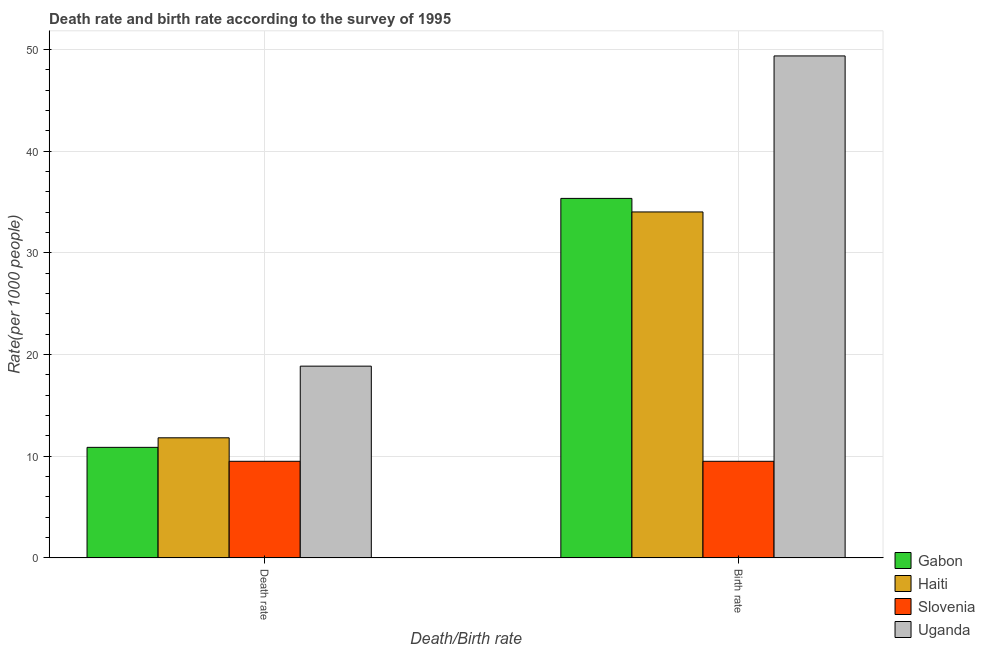How many different coloured bars are there?
Give a very brief answer. 4. Are the number of bars per tick equal to the number of legend labels?
Provide a succinct answer. Yes. Are the number of bars on each tick of the X-axis equal?
Your response must be concise. Yes. How many bars are there on the 1st tick from the left?
Offer a very short reply. 4. What is the label of the 1st group of bars from the left?
Give a very brief answer. Death rate. What is the birth rate in Gabon?
Provide a succinct answer. 35.35. Across all countries, what is the maximum birth rate?
Offer a terse response. 49.36. In which country was the birth rate maximum?
Keep it short and to the point. Uganda. In which country was the birth rate minimum?
Keep it short and to the point. Slovenia. What is the total birth rate in the graph?
Make the answer very short. 128.23. What is the difference between the death rate in Uganda and that in Gabon?
Offer a very short reply. 7.99. What is the difference between the birth rate in Gabon and the death rate in Haiti?
Offer a very short reply. 23.54. What is the average birth rate per country?
Provide a short and direct response. 32.06. What is the difference between the death rate and birth rate in Uganda?
Keep it short and to the point. -30.51. In how many countries, is the birth rate greater than 48 ?
Provide a short and direct response. 1. What is the ratio of the death rate in Uganda to that in Haiti?
Provide a short and direct response. 1.6. What does the 2nd bar from the left in Birth rate represents?
Give a very brief answer. Haiti. What does the 3rd bar from the right in Death rate represents?
Keep it short and to the point. Haiti. Are the values on the major ticks of Y-axis written in scientific E-notation?
Keep it short and to the point. No. Does the graph contain grids?
Make the answer very short. Yes. What is the title of the graph?
Make the answer very short. Death rate and birth rate according to the survey of 1995. What is the label or title of the X-axis?
Provide a succinct answer. Death/Birth rate. What is the label or title of the Y-axis?
Provide a short and direct response. Rate(per 1000 people). What is the Rate(per 1000 people) in Gabon in Death rate?
Keep it short and to the point. 10.87. What is the Rate(per 1000 people) in Haiti in Death rate?
Your answer should be compact. 11.81. What is the Rate(per 1000 people) in Slovenia in Death rate?
Your answer should be very brief. 9.5. What is the Rate(per 1000 people) in Uganda in Death rate?
Keep it short and to the point. 18.86. What is the Rate(per 1000 people) in Gabon in Birth rate?
Provide a succinct answer. 35.35. What is the Rate(per 1000 people) in Haiti in Birth rate?
Your answer should be very brief. 34.02. What is the Rate(per 1000 people) of Slovenia in Birth rate?
Make the answer very short. 9.5. What is the Rate(per 1000 people) of Uganda in Birth rate?
Your answer should be very brief. 49.36. Across all Death/Birth rate, what is the maximum Rate(per 1000 people) of Gabon?
Provide a succinct answer. 35.35. Across all Death/Birth rate, what is the maximum Rate(per 1000 people) in Haiti?
Your response must be concise. 34.02. Across all Death/Birth rate, what is the maximum Rate(per 1000 people) of Uganda?
Provide a short and direct response. 49.36. Across all Death/Birth rate, what is the minimum Rate(per 1000 people) in Gabon?
Offer a very short reply. 10.87. Across all Death/Birth rate, what is the minimum Rate(per 1000 people) in Haiti?
Your answer should be very brief. 11.81. Across all Death/Birth rate, what is the minimum Rate(per 1000 people) of Uganda?
Ensure brevity in your answer.  18.86. What is the total Rate(per 1000 people) of Gabon in the graph?
Keep it short and to the point. 46.22. What is the total Rate(per 1000 people) in Haiti in the graph?
Provide a short and direct response. 45.83. What is the total Rate(per 1000 people) of Uganda in the graph?
Offer a terse response. 68.22. What is the difference between the Rate(per 1000 people) in Gabon in Death rate and that in Birth rate?
Ensure brevity in your answer.  -24.48. What is the difference between the Rate(per 1000 people) in Haiti in Death rate and that in Birth rate?
Your answer should be compact. -22.21. What is the difference between the Rate(per 1000 people) of Slovenia in Death rate and that in Birth rate?
Give a very brief answer. 0. What is the difference between the Rate(per 1000 people) of Uganda in Death rate and that in Birth rate?
Ensure brevity in your answer.  -30.51. What is the difference between the Rate(per 1000 people) of Gabon in Death rate and the Rate(per 1000 people) of Haiti in Birth rate?
Keep it short and to the point. -23.15. What is the difference between the Rate(per 1000 people) in Gabon in Death rate and the Rate(per 1000 people) in Slovenia in Birth rate?
Give a very brief answer. 1.37. What is the difference between the Rate(per 1000 people) of Gabon in Death rate and the Rate(per 1000 people) of Uganda in Birth rate?
Ensure brevity in your answer.  -38.49. What is the difference between the Rate(per 1000 people) of Haiti in Death rate and the Rate(per 1000 people) of Slovenia in Birth rate?
Offer a very short reply. 2.31. What is the difference between the Rate(per 1000 people) in Haiti in Death rate and the Rate(per 1000 people) in Uganda in Birth rate?
Your answer should be very brief. -37.55. What is the difference between the Rate(per 1000 people) of Slovenia in Death rate and the Rate(per 1000 people) of Uganda in Birth rate?
Offer a very short reply. -39.86. What is the average Rate(per 1000 people) of Gabon per Death/Birth rate?
Your answer should be compact. 23.11. What is the average Rate(per 1000 people) in Haiti per Death/Birth rate?
Your response must be concise. 22.91. What is the average Rate(per 1000 people) of Uganda per Death/Birth rate?
Offer a very short reply. 34.11. What is the difference between the Rate(per 1000 people) in Gabon and Rate(per 1000 people) in Haiti in Death rate?
Offer a terse response. -0.94. What is the difference between the Rate(per 1000 people) in Gabon and Rate(per 1000 people) in Slovenia in Death rate?
Make the answer very short. 1.37. What is the difference between the Rate(per 1000 people) of Gabon and Rate(per 1000 people) of Uganda in Death rate?
Provide a short and direct response. -7.99. What is the difference between the Rate(per 1000 people) of Haiti and Rate(per 1000 people) of Slovenia in Death rate?
Provide a short and direct response. 2.31. What is the difference between the Rate(per 1000 people) in Haiti and Rate(per 1000 people) in Uganda in Death rate?
Provide a short and direct response. -7.05. What is the difference between the Rate(per 1000 people) of Slovenia and Rate(per 1000 people) of Uganda in Death rate?
Provide a short and direct response. -9.36. What is the difference between the Rate(per 1000 people) in Gabon and Rate(per 1000 people) in Haiti in Birth rate?
Your answer should be very brief. 1.33. What is the difference between the Rate(per 1000 people) of Gabon and Rate(per 1000 people) of Slovenia in Birth rate?
Provide a succinct answer. 25.85. What is the difference between the Rate(per 1000 people) of Gabon and Rate(per 1000 people) of Uganda in Birth rate?
Offer a very short reply. -14.01. What is the difference between the Rate(per 1000 people) of Haiti and Rate(per 1000 people) of Slovenia in Birth rate?
Your answer should be compact. 24.52. What is the difference between the Rate(per 1000 people) in Haiti and Rate(per 1000 people) in Uganda in Birth rate?
Keep it short and to the point. -15.34. What is the difference between the Rate(per 1000 people) in Slovenia and Rate(per 1000 people) in Uganda in Birth rate?
Make the answer very short. -39.86. What is the ratio of the Rate(per 1000 people) of Gabon in Death rate to that in Birth rate?
Ensure brevity in your answer.  0.31. What is the ratio of the Rate(per 1000 people) of Haiti in Death rate to that in Birth rate?
Your answer should be compact. 0.35. What is the ratio of the Rate(per 1000 people) of Uganda in Death rate to that in Birth rate?
Give a very brief answer. 0.38. What is the difference between the highest and the second highest Rate(per 1000 people) in Gabon?
Your answer should be compact. 24.48. What is the difference between the highest and the second highest Rate(per 1000 people) in Haiti?
Offer a very short reply. 22.21. What is the difference between the highest and the second highest Rate(per 1000 people) in Uganda?
Keep it short and to the point. 30.51. What is the difference between the highest and the lowest Rate(per 1000 people) in Gabon?
Provide a short and direct response. 24.48. What is the difference between the highest and the lowest Rate(per 1000 people) of Haiti?
Keep it short and to the point. 22.21. What is the difference between the highest and the lowest Rate(per 1000 people) in Uganda?
Keep it short and to the point. 30.51. 